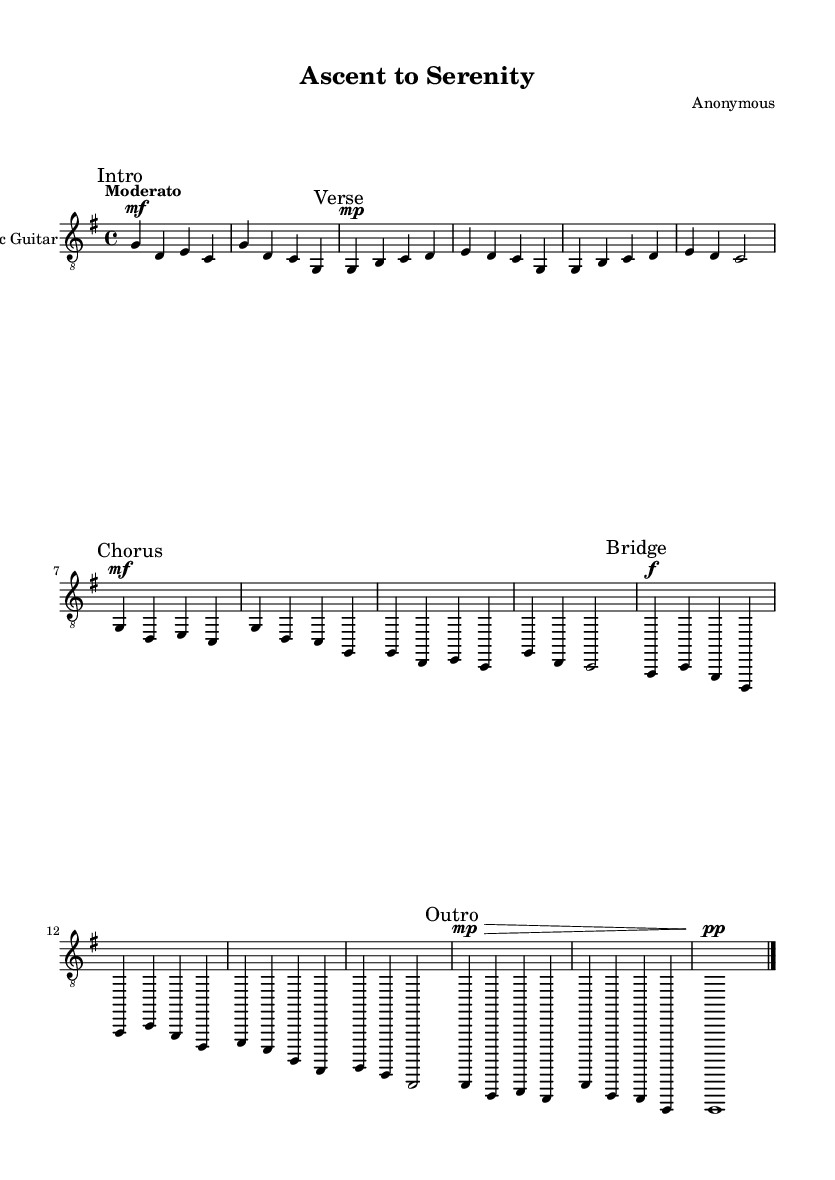What is the key signature of this music? The key signature is indicated at the beginning of the music; it shows one sharp, which corresponds to G major.
Answer: G major What is the time signature of this piece? The time signature is written next to the clef at the beginning of the music, which indicates 4 beats per measure.
Answer: 4/4 What is the tempo marking of this music? The tempo marking is placed at the beginning, stating "Moderato," which indicates a moderate speed for the piece.
Answer: Moderato How many measures are in the intro section? By counting the number of vertical lines representing measures in the "Intro" section, we see there are two measures.
Answer: 2 What dynamic marking is used in the Chorus section? The dynamic marking in the Chorus is indicated by "mf," which means mezzo-forte, or moderately loud.
Answer: mezzo-forte Which section contains the fastest dynamic marked "f"? The "Bridge" section contains the fastest dynamic marking, indicated by "f," which is fortissimo, or very loud.
Answer: Bridge What musical form does this piece most closely follow? The piece follows a structure that includes an Intro, Verse, Chorus, Bridge, and Outro, indicating a common song form.
Answer: Verse-Chorus structure 